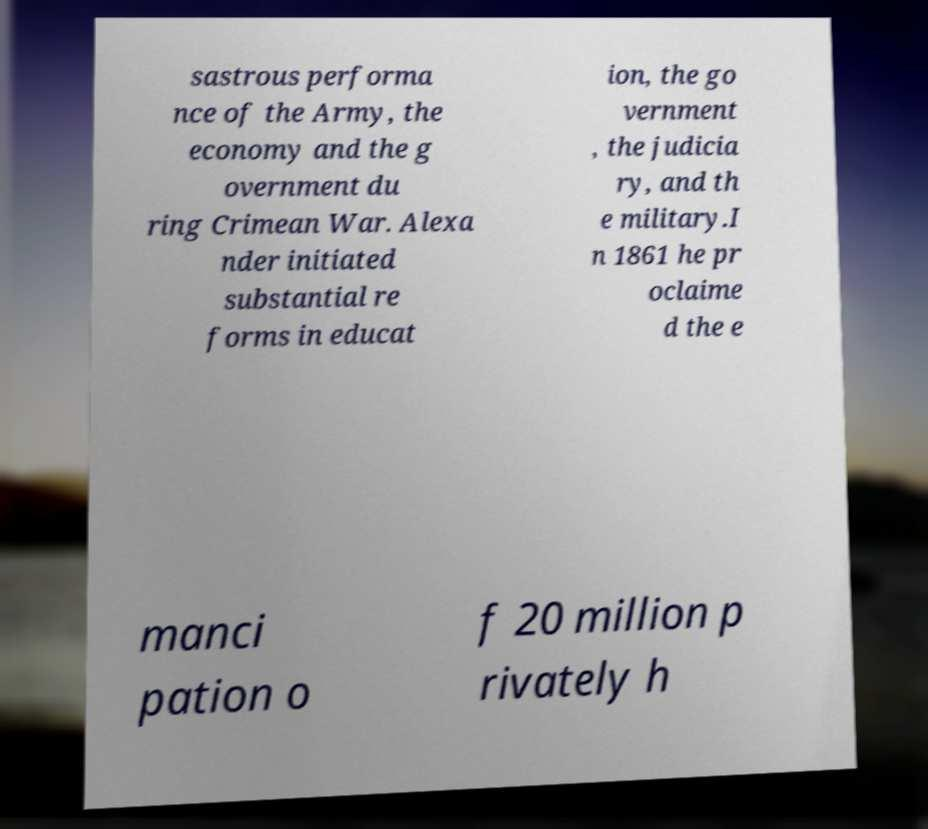Please read and relay the text visible in this image. What does it say? sastrous performa nce of the Army, the economy and the g overnment du ring Crimean War. Alexa nder initiated substantial re forms in educat ion, the go vernment , the judicia ry, and th e military.I n 1861 he pr oclaime d the e manci pation o f 20 million p rivately h 